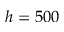Convert formula to latex. <formula><loc_0><loc_0><loc_500><loc_500>h = 5 0 0</formula> 